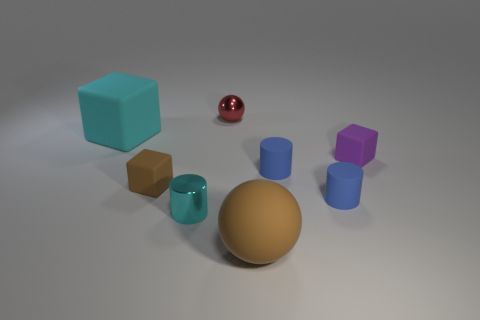What is the shape of the big rubber object that is to the right of the large thing that is on the left side of the ball that is right of the metallic ball?
Make the answer very short. Sphere. Are there fewer small cylinders on the left side of the brown cube than balls behind the cyan block?
Keep it short and to the point. Yes. Do the shiny object in front of the tiny red metal thing and the big thing on the right side of the cyan cube have the same shape?
Your response must be concise. No. There is a big thing behind the big object in front of the tiny purple matte cube; what shape is it?
Provide a succinct answer. Cube. There is a shiny thing that is the same color as the big matte block; what size is it?
Your answer should be very brief. Small. Is there a small cyan cylinder that has the same material as the red object?
Provide a short and direct response. Yes. What is the cyan thing left of the cyan cylinder made of?
Give a very brief answer. Rubber. What material is the brown block?
Give a very brief answer. Rubber. Does the tiny object that is behind the cyan rubber cube have the same material as the tiny purple object?
Your response must be concise. No. Is the number of brown matte objects behind the tiny metallic ball less than the number of tiny purple shiny things?
Your answer should be compact. No. 